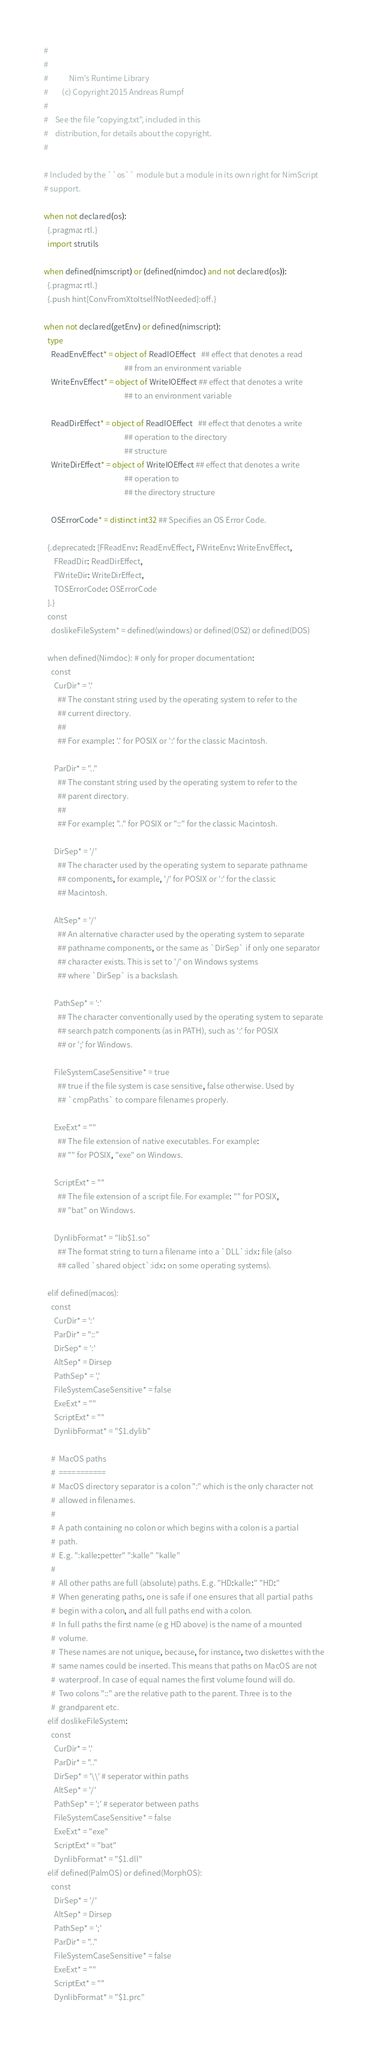<code> <loc_0><loc_0><loc_500><loc_500><_Nim_>#
#
#            Nim's Runtime Library
#        (c) Copyright 2015 Andreas Rumpf
#
#    See the file "copying.txt", included in this
#    distribution, for details about the copyright.
#

# Included by the ``os`` module but a module in its own right for NimScript
# support.

when not declared(os):
  {.pragma: rtl.}
  import strutils

when defined(nimscript) or (defined(nimdoc) and not declared(os)):
  {.pragma: rtl.}
  {.push hint[ConvFromXtoItselfNotNeeded]:off.}

when not declared(getEnv) or defined(nimscript):
  type
    ReadEnvEffect* = object of ReadIOEffect   ## effect that denotes a read
                                              ## from an environment variable
    WriteEnvEffect* = object of WriteIOEffect ## effect that denotes a write
                                              ## to an environment variable

    ReadDirEffect* = object of ReadIOEffect   ## effect that denotes a write
                                              ## operation to the directory
                                              ## structure
    WriteDirEffect* = object of WriteIOEffect ## effect that denotes a write
                                              ## operation to
                                              ## the directory structure

    OSErrorCode* = distinct int32 ## Specifies an OS Error Code.

  {.deprecated: [FReadEnv: ReadEnvEffect, FWriteEnv: WriteEnvEffect,
      FReadDir: ReadDirEffect,
      FWriteDir: WriteDirEffect,
      TOSErrorCode: OSErrorCode
  ].}
  const
    doslikeFileSystem* = defined(windows) or defined(OS2) or defined(DOS)

  when defined(Nimdoc): # only for proper documentation:
    const
      CurDir* = '.'
        ## The constant string used by the operating system to refer to the
        ## current directory.
        ##
        ## For example: '.' for POSIX or ':' for the classic Macintosh.

      ParDir* = ".."
        ## The constant string used by the operating system to refer to the
        ## parent directory.
        ##
        ## For example: ".." for POSIX or "::" for the classic Macintosh.

      DirSep* = '/'
        ## The character used by the operating system to separate pathname
        ## components, for example, '/' for POSIX or ':' for the classic
        ## Macintosh.

      AltSep* = '/'
        ## An alternative character used by the operating system to separate
        ## pathname components, or the same as `DirSep` if only one separator
        ## character exists. This is set to '/' on Windows systems
        ## where `DirSep` is a backslash.

      PathSep* = ':'
        ## The character conventionally used by the operating system to separate
        ## search patch components (as in PATH), such as ':' for POSIX
        ## or ';' for Windows.

      FileSystemCaseSensitive* = true
        ## true if the file system is case sensitive, false otherwise. Used by
        ## `cmpPaths` to compare filenames properly.

      ExeExt* = ""
        ## The file extension of native executables. For example:
        ## "" for POSIX, "exe" on Windows.

      ScriptExt* = ""
        ## The file extension of a script file. For example: "" for POSIX,
        ## "bat" on Windows.

      DynlibFormat* = "lib$1.so"
        ## The format string to turn a filename into a `DLL`:idx: file (also
        ## called `shared object`:idx: on some operating systems).

  elif defined(macos):
    const
      CurDir* = ':'
      ParDir* = "::"
      DirSep* = ':'
      AltSep* = Dirsep
      PathSep* = ','
      FileSystemCaseSensitive* = false
      ExeExt* = ""
      ScriptExt* = ""
      DynlibFormat* = "$1.dylib"

    #  MacOS paths
    #  ===========
    #  MacOS directory separator is a colon ":" which is the only character not
    #  allowed in filenames.
    #
    #  A path containing no colon or which begins with a colon is a partial
    #  path.
    #  E.g. ":kalle:petter" ":kalle" "kalle"
    #
    #  All other paths are full (absolute) paths. E.g. "HD:kalle:" "HD:"
    #  When generating paths, one is safe if one ensures that all partial paths
    #  begin with a colon, and all full paths end with a colon.
    #  In full paths the first name (e g HD above) is the name of a mounted
    #  volume.
    #  These names are not unique, because, for instance, two diskettes with the
    #  same names could be inserted. This means that paths on MacOS are not
    #  waterproof. In case of equal names the first volume found will do.
    #  Two colons "::" are the relative path to the parent. Three is to the
    #  grandparent etc.
  elif doslikeFileSystem:
    const
      CurDir* = '.'
      ParDir* = ".."
      DirSep* = '\\' # seperator within paths
      AltSep* = '/'
      PathSep* = ';' # seperator between paths
      FileSystemCaseSensitive* = false
      ExeExt* = "exe"
      ScriptExt* = "bat"
      DynlibFormat* = "$1.dll"
  elif defined(PalmOS) or defined(MorphOS):
    const
      DirSep* = '/'
      AltSep* = Dirsep
      PathSep* = ';'
      ParDir* = ".."
      FileSystemCaseSensitive* = false
      ExeExt* = ""
      ScriptExt* = ""
      DynlibFormat* = "$1.prc"</code> 